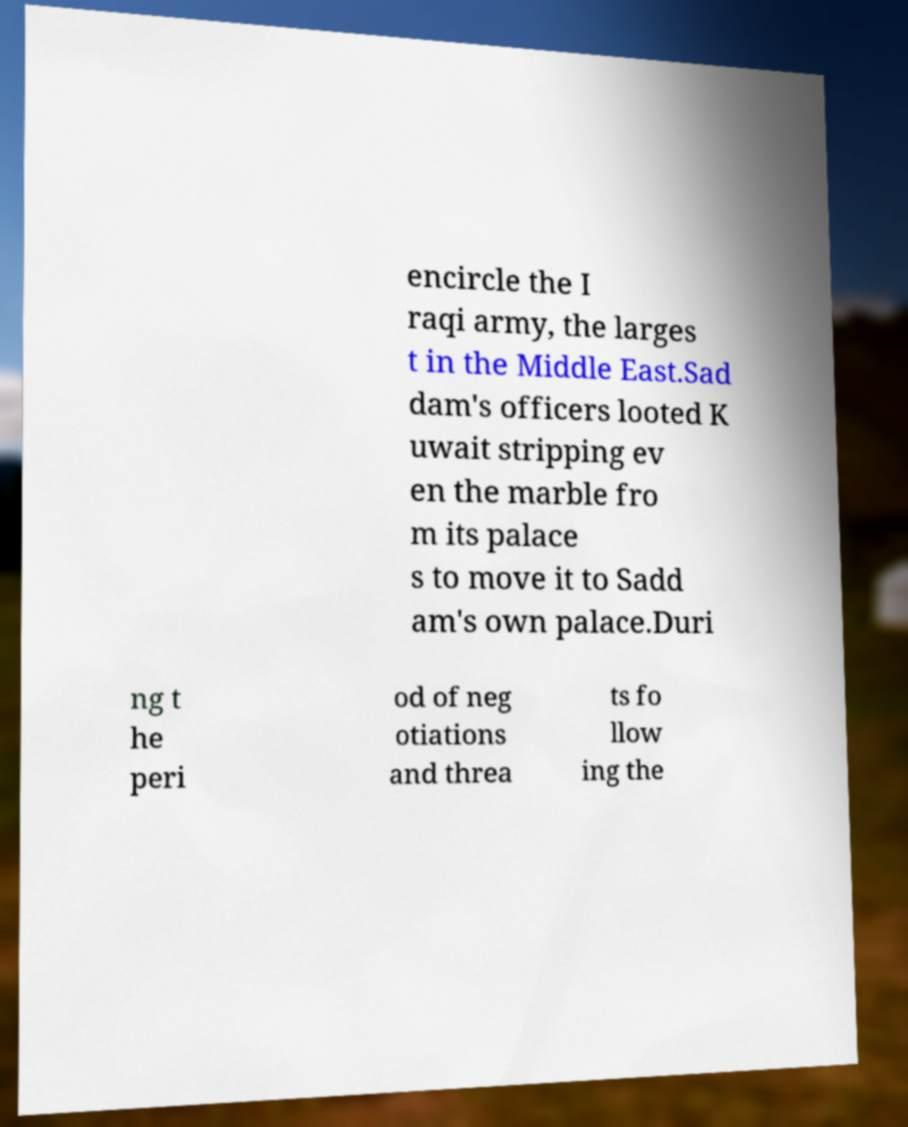For documentation purposes, I need the text within this image transcribed. Could you provide that? encircle the I raqi army, the larges t in the Middle East.Sad dam's officers looted K uwait stripping ev en the marble fro m its palace s to move it to Sadd am's own palace.Duri ng t he peri od of neg otiations and threa ts fo llow ing the 